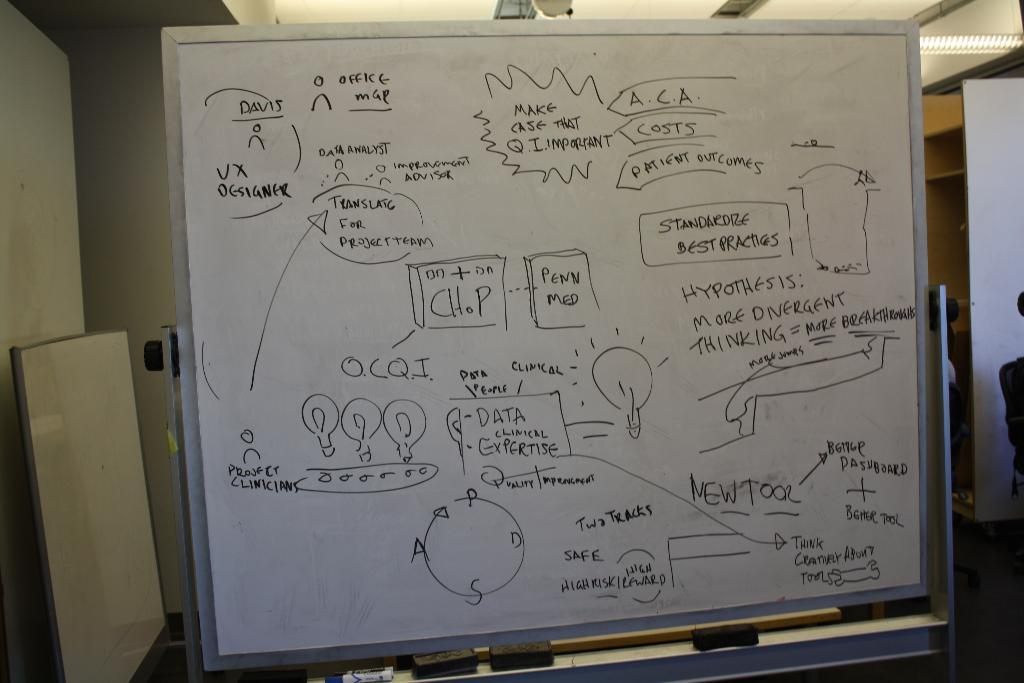<image>
Share a concise interpretation of the image provided. White board that says Make Case That Q.I important in a bubble. 